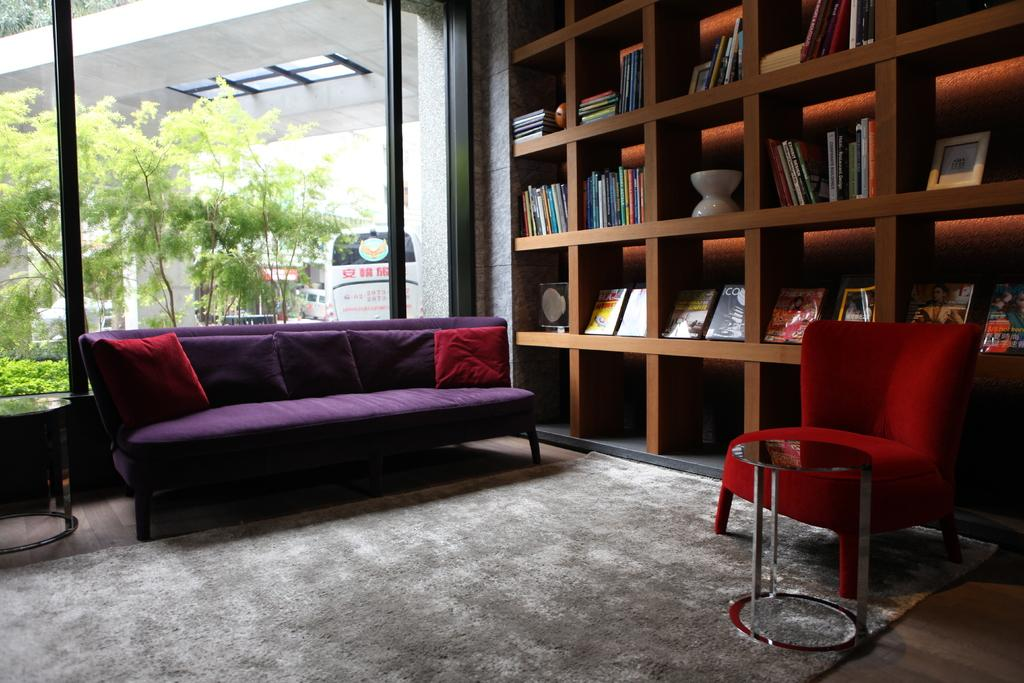What type of furniture is located on the left side of the image? There is a sofa on the left side of the image. What can be seen on the right side of the image? There is a bookshelf on the right side of the image. What feature allows natural light to enter the room in the image? There is a window in the image. How many horses are visible in the image? There are no horses present in the image. What type of chalk is being used to draw on the bookshelf? There is no chalk or drawing activity present in the image. 